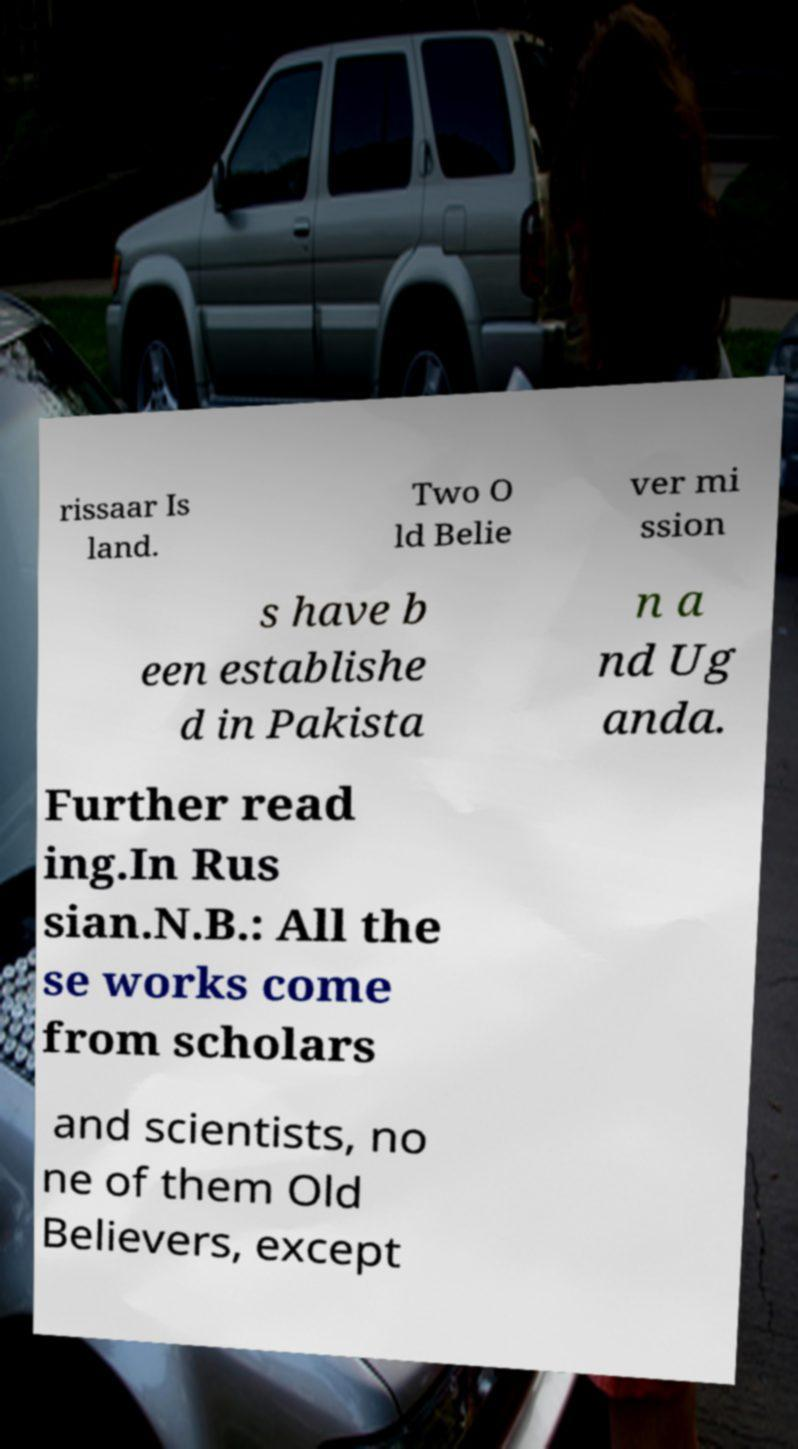There's text embedded in this image that I need extracted. Can you transcribe it verbatim? rissaar Is land. Two O ld Belie ver mi ssion s have b een establishe d in Pakista n a nd Ug anda. Further read ing.In Rus sian.N.B.: All the se works come from scholars and scientists, no ne of them Old Believers, except 